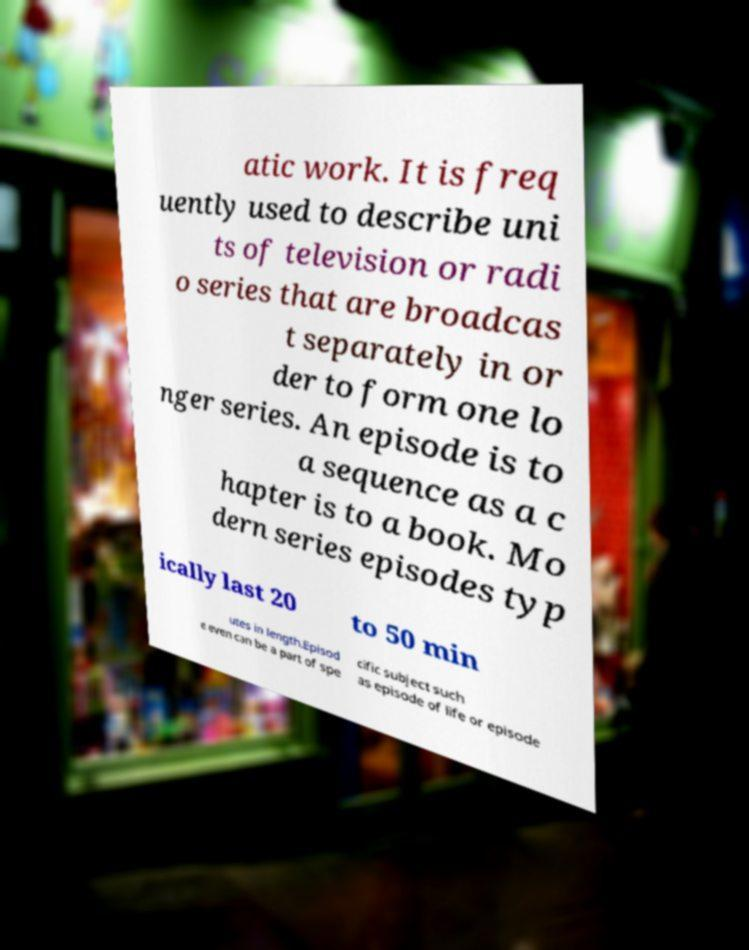Can you accurately transcribe the text from the provided image for me? atic work. It is freq uently used to describe uni ts of television or radi o series that are broadcas t separately in or der to form one lo nger series. An episode is to a sequence as a c hapter is to a book. Mo dern series episodes typ ically last 20 to 50 min utes in length.Episod e even can be a part of spe cific subject such as episode of life or episode 